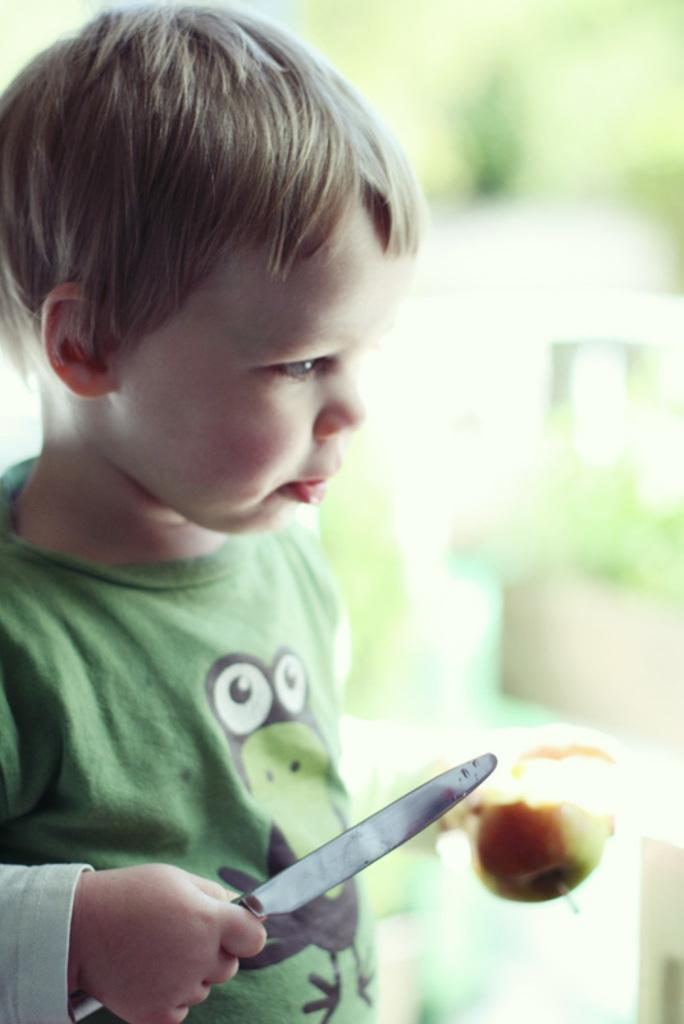Who is in the image? There is a boy in the image. What is the boy holding in his hand? The boy is holding a knife and a fruit. What color is the throne in the image? There is no throne present in the image. 